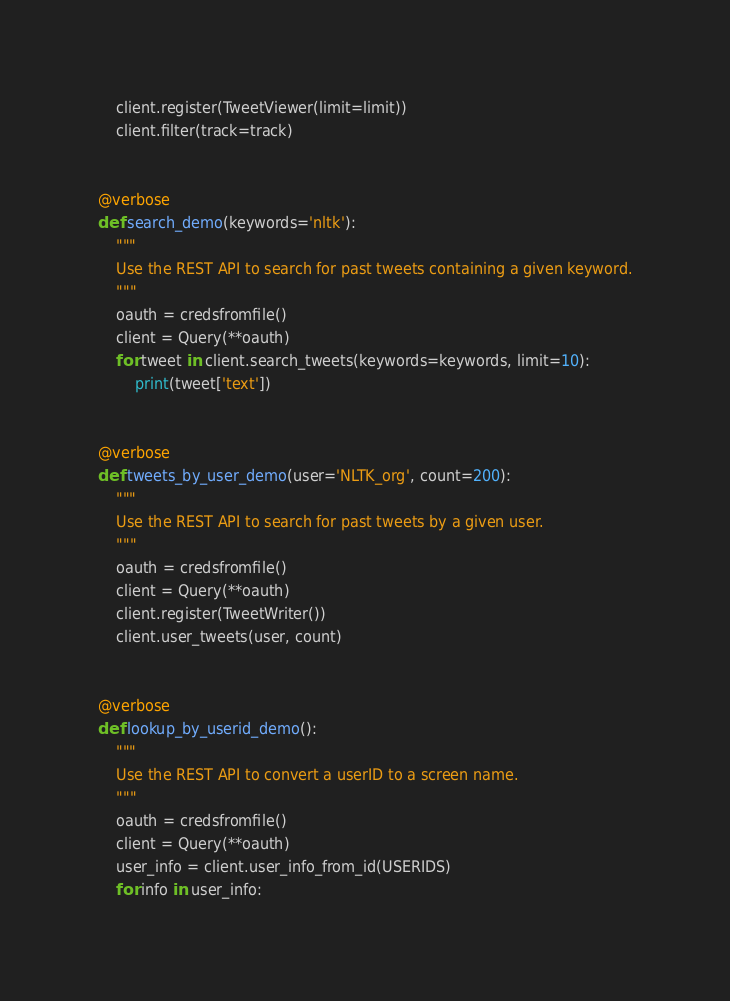Convert code to text. <code><loc_0><loc_0><loc_500><loc_500><_Python_>    client.register(TweetViewer(limit=limit))
    client.filter(track=track)


@verbose
def search_demo(keywords='nltk'):
    """
    Use the REST API to search for past tweets containing a given keyword.
    """
    oauth = credsfromfile()
    client = Query(**oauth)
    for tweet in client.search_tweets(keywords=keywords, limit=10):
        print(tweet['text'])


@verbose
def tweets_by_user_demo(user='NLTK_org', count=200):
    """
    Use the REST API to search for past tweets by a given user.
    """
    oauth = credsfromfile()
    client = Query(**oauth)
    client.register(TweetWriter())
    client.user_tweets(user, count)


@verbose
def lookup_by_userid_demo():
    """
    Use the REST API to convert a userID to a screen name.
    """
    oauth = credsfromfile()
    client = Query(**oauth)
    user_info = client.user_info_from_id(USERIDS)
    for info in user_info:</code> 